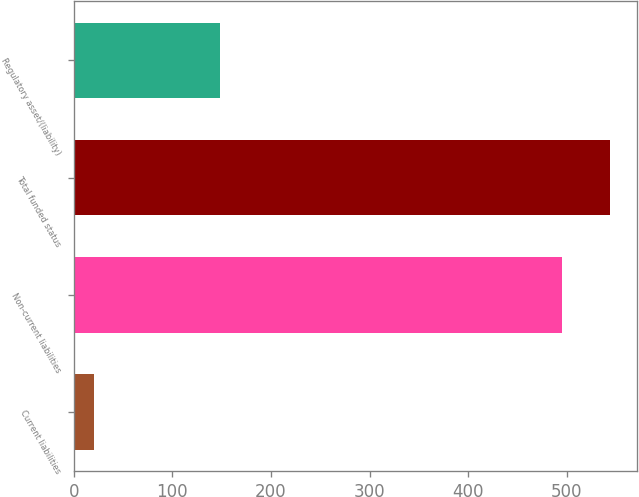Convert chart to OTSL. <chart><loc_0><loc_0><loc_500><loc_500><bar_chart><fcel>Current liabilities<fcel>Non-current liabilities<fcel>Total funded status<fcel>Regulatory asset/(liability)<nl><fcel>20<fcel>495<fcel>544.5<fcel>148<nl></chart> 